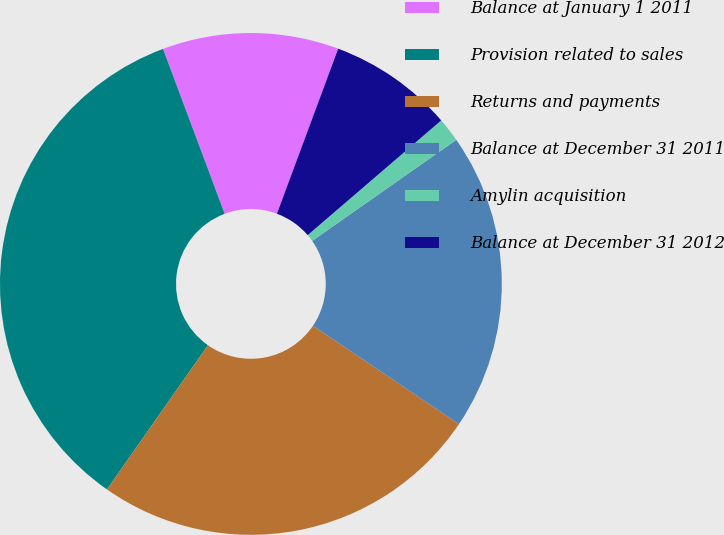Convert chart. <chart><loc_0><loc_0><loc_500><loc_500><pie_chart><fcel>Balance at January 1 2011<fcel>Provision related to sales<fcel>Returns and payments<fcel>Balance at December 31 2011<fcel>Amylin acquisition<fcel>Balance at December 31 2012<nl><fcel>11.35%<fcel>34.58%<fcel>25.29%<fcel>19.17%<fcel>1.56%<fcel>8.05%<nl></chart> 